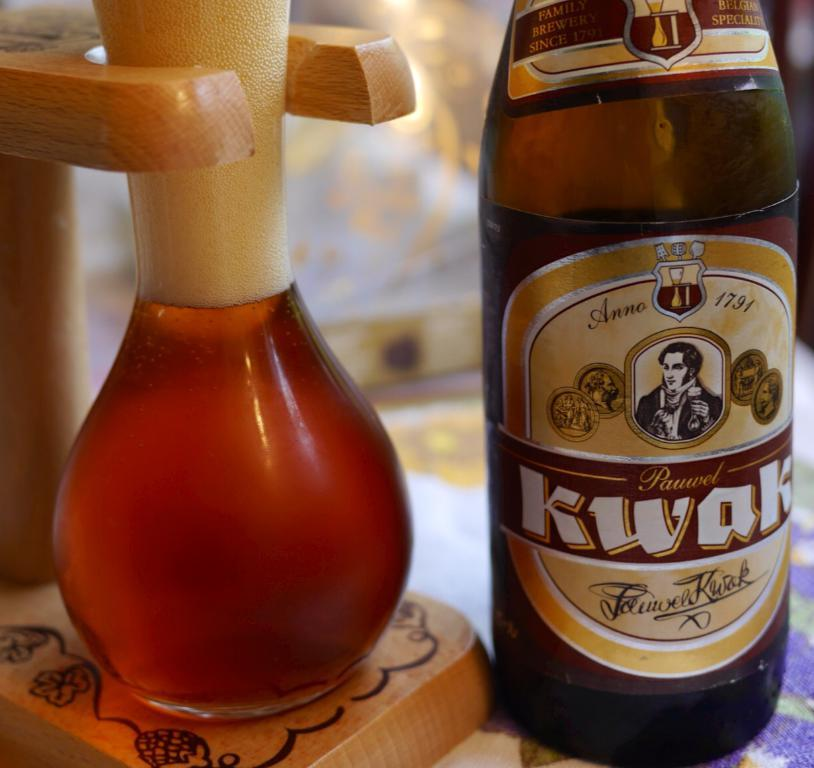<image>
Create a compact narrative representing the image presented. The beer in the container is Pauwel Kwak. 